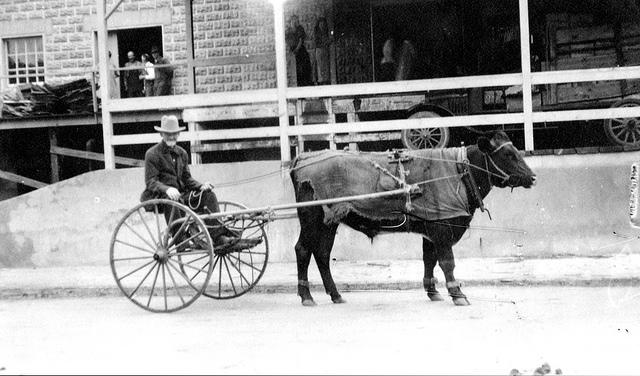What color  is the photo?
Be succinct. Black and white. What is drawing the man seated in the cart?
Answer briefly. Cow. What are these animals pulling?
Be succinct. Cart. What species of animals are these?
Short answer required. Cow. What kind of animal is pulling the man?
Short answer required. Cow. Who does the sign say to vote for?
Give a very brief answer. No one. Is the horse walking on pavement?
Concise answer only. Yes. How many people would fit on this carriage?
Quick response, please. 1. 